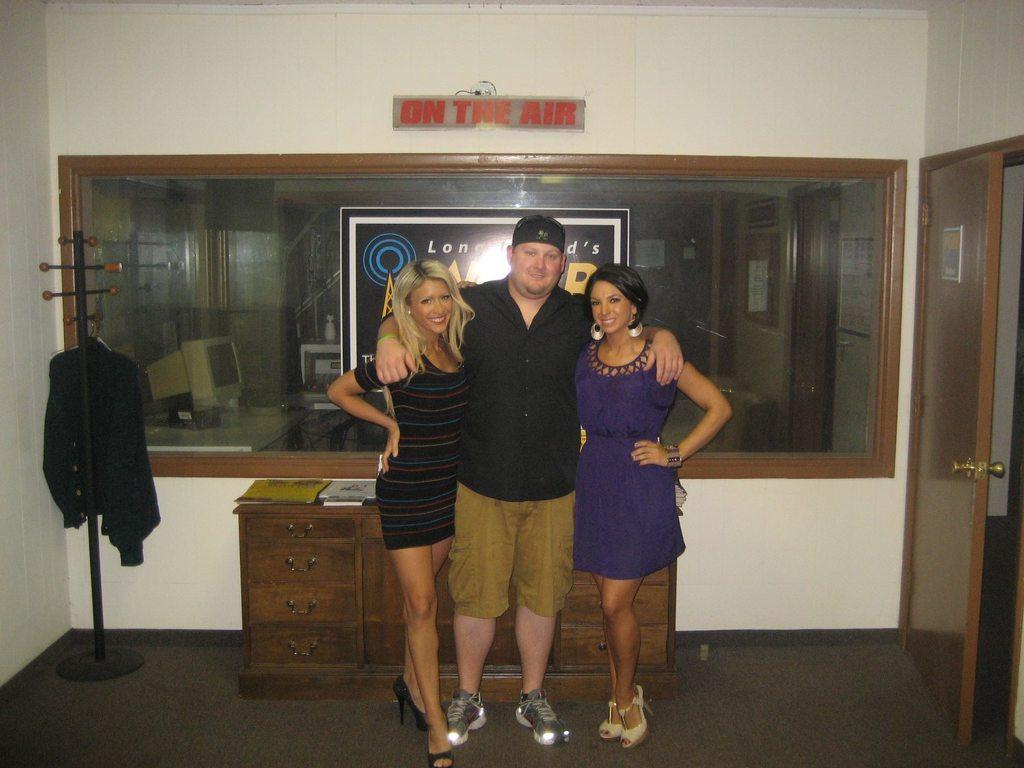Can you describe this image briefly? In this picture I can see three persons standing, there is a cupboard with drawers, there is a cloth to a hanger, there are boards and a door, and in the background there is a transparent glass. Through the transparent glass, I can see some objects. 